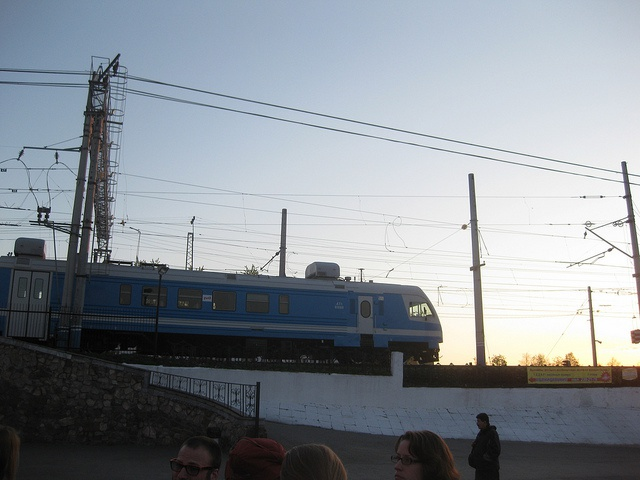Describe the objects in this image and their specific colors. I can see train in gray, black, navy, and darkblue tones, people in gray, black, and maroon tones, people in black, maroon, and gray tones, people in gray, black, and maroon tones, and people in gray and black tones in this image. 